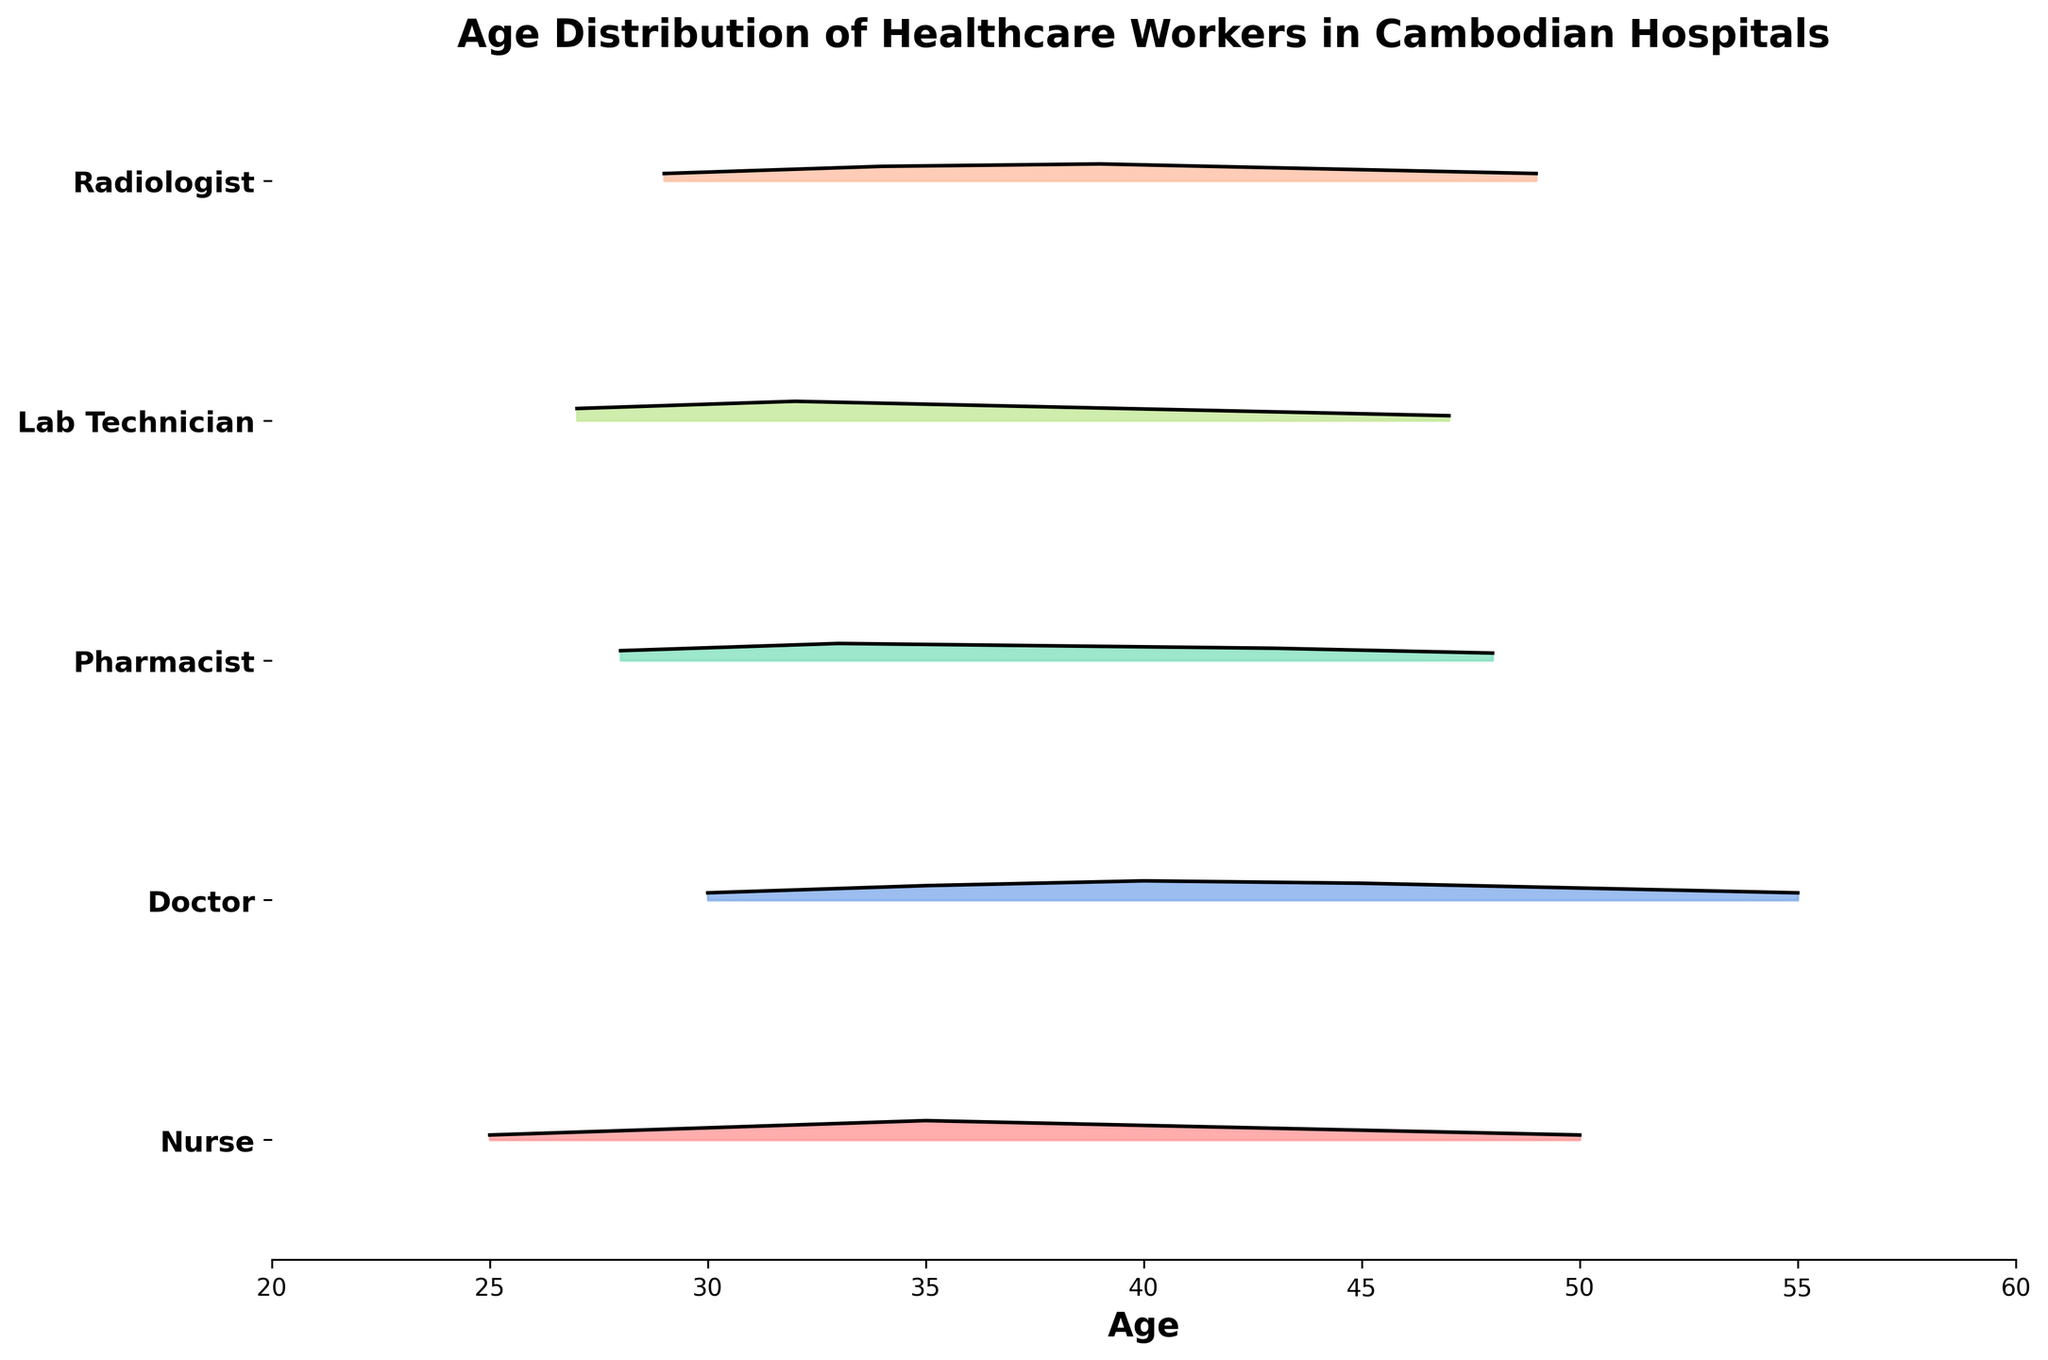What is the title of the figure? The title is usually placed at the top of the figure. It reads "Age Distribution of Healthcare Workers in Cambodian Hospitals."
Answer: Age Distribution of Healthcare Workers in Cambodian Hospitals Which role has the highest density at age 35? Look at the density values for each role at age 35, then identify the highest one. For Nurses, it's 0.08; for Doctors, it's 0.06; for Pharmacists, it's 0.03, and for Lab Technicians and Radiologists, there's no data at age 35. Hence, Nurses have the highest density at 35.
Answer: Nurse What is the x-axis representing? The x-axis labels usually indicate what the axis represents, which in this case, is the 'Age' of healthcare workers.
Answer: Age Which role's density peaks at age 40? Identify the highest density value for each role and determine if it's at age 40. Nurses' density peaks at 0.08, Doctors at 0.08, Pharmacists at 0.07, Lab Technicians at 0.08, and Radiologists at 0.07. Both Nurses and Doctors peak at age 40.
Answer: Nurses and Doctors How many different roles are represented in the plot? Count the unique labels on the y-axis, which are Nurses, Doctors, Pharmacists, Lab Technicians, and Radiologists.
Answer: 5 Which role has the broadest age distribution range? Visualize which role spans the widest range of ages. Nurses go from 25 to 50; Doctors from 30 to 55; Pharmacists from 28 to 48; Lab Technicians from 27 to 47; Radiologists from 29 to 49. Doctors cover the widest range (25 years).
Answer: Doctor What is the common density value at age 50 for roles that have data at that age? Look at the density values for age 50. Nurses have 0.02 and Doctors have 0.05. Pharmacists, Lab Technicians, and Radiologists don't have data at age 50.
Answer: 0.02 and 0.05 Do more roles peak in density around age 40 or age 45? Check the density peaks around age 40 and 45. At age 40, Nurses, Doctors, and Lab Technicians peak. At age 45, Doctors peak. Hence, more roles peak at age 40.
Answer: Age 40 What is the range of ages for Lab Technicians in the plot? Check the lowest and highest ages plotted for Lab Technicians, which are 27 to 47.
Answer: 27 to 47 